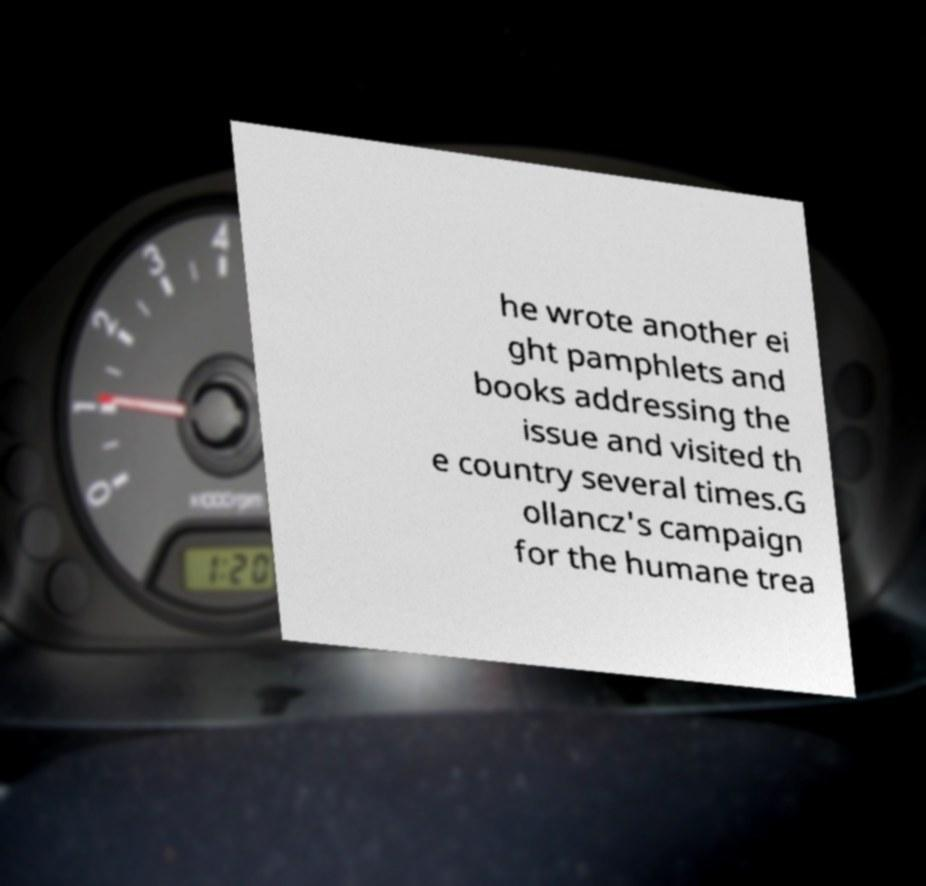What messages or text are displayed in this image? I need them in a readable, typed format. he wrote another ei ght pamphlets and books addressing the issue and visited th e country several times.G ollancz's campaign for the humane trea 